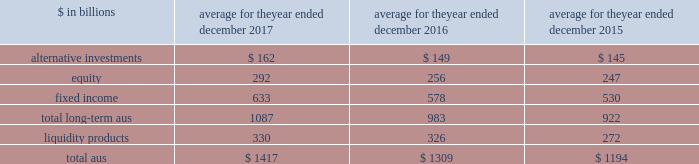The goldman sachs group , inc .
And subsidiaries management 2019s discussion and analysis the table below presents our average monthly assets under supervision by asset class .
Average for the year ended december $ in billions 2017 2016 2015 .
Operating environment .
During 2017 , investment management operated in an environment characterized by generally higher asset prices , resulting in appreciation in both equity and fixed income assets .
In addition , our long- term assets under supervision increased from net inflows primarily in fixed income and alternative investment assets .
These increases were partially offset by net outflows in liquidity products .
As a result , the mix of average assets under supervision during 2017 shifted slightly from liquidity products to long-term assets under supervision as compared to the mix at the end of 2016 .
In the future , if asset prices decline , or investors favor assets that typically generate lower fees or investors withdraw their assets , net revenues in investment management would likely be negatively impacted .
Following a challenging first quarter of 2016 , market conditions improved during the remainder of 2016 with higher asset prices resulting in full year appreciation in both equity and fixed income assets .
Also , our assets under supervision increased during 2016 from net inflows , primarily in fixed income assets , and liquidity products .
The mix of our average assets under supervision shifted slightly compared with 2015 from long-term assets under supervision to liquidity products .
Management fees were impacted by many factors , including inflows to advisory services and outflows from actively-managed mutual funds .
2017 versus 2016 .
Net revenues in investment management were $ 6.22 billion for 2017 , 7% ( 7 % ) higher than 2016 , due to higher management and other fees , reflecting higher average assets under supervision , and higher transaction revenues .
During the year , total assets under supervision increased $ 115 billion to $ 1.49 trillion .
Long- term assets under supervision increased $ 128 billion , including net market appreciation of $ 86 billion , primarily in equity and fixed income assets , and net inflows of $ 42 billion ( which includes $ 20 billion of inflows in connection with the verus acquisition and $ 5 billion of equity asset outflows in connection with the australian divestiture ) , primarily in fixed income and alternative investment assets .
Liquidity products decreased $ 13 billion ( which includes $ 3 billion of inflows in connection with the verus acquisition ) .
Operating expenses were $ 4.80 billion for 2017 , 3% ( 3 % ) higher than 2016 , primarily due to increased compensation and benefits expenses , reflecting higher net revenues .
Pre-tax earnings were $ 1.42 billion in 2017 , 25% ( 25 % ) higher than 2016 versus 2015 .
Net revenues in investment management were $ 5.79 billion for 2016 , 7% ( 7 % ) lower than 2015 .
This decrease primarily reflected significantly lower incentive fees compared with a strong 2015 .
In addition , management and other fees were slightly lower , reflecting shifts in the mix of client assets and strategies , partially offset by the impact of higher average assets under supervision .
During 2016 , total assets under supervision increased $ 127 billion to $ 1.38 trillion .
Long-term assets under supervision increased $ 75 billion , including net inflows of $ 42 billion , primarily in fixed income assets , and net market appreciation of $ 33 billion , primarily in equity and fixed income assets .
In addition , liquidity products increased $ 52 billion .
Operating expenses were $ 4.65 billion for 2016 , 4% ( 4 % ) lower than 2015 , due to decreased compensation and benefits expenses , reflecting lower net revenues .
Pre-tax earnings were $ 1.13 billion in 2016 , 17% ( 17 % ) lower than 2015 .
Geographic data see note 25 to the consolidated financial statements for a summary of our total net revenues , pre-tax earnings and net earnings by geographic region .
Goldman sachs 2017 form 10-k 63 .
Long- term assets under supervision , in billions , were what excluding net market appreciation? 
Computations: (128 - 86)
Answer: 42.0. 